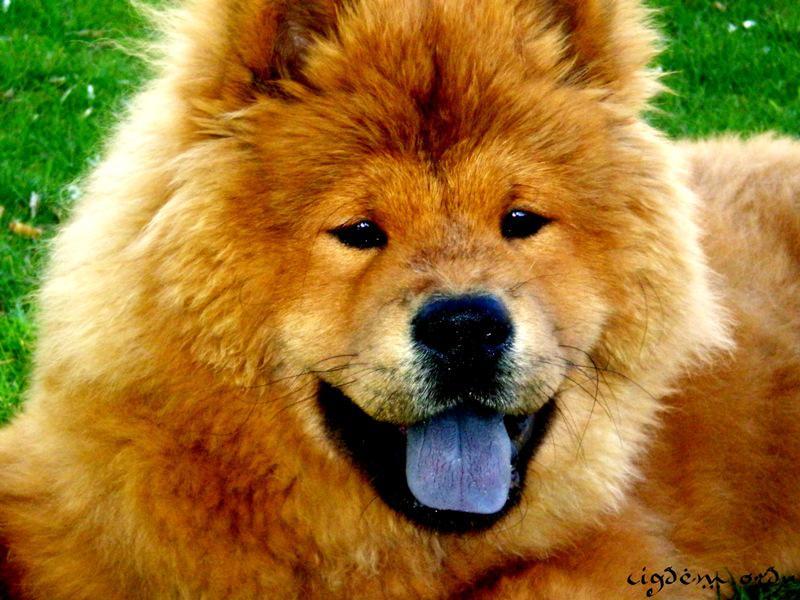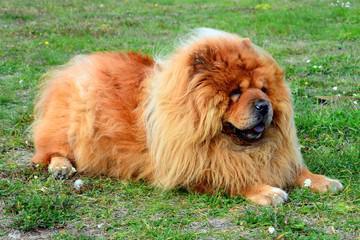The first image is the image on the left, the second image is the image on the right. For the images displayed, is the sentence "The right image includes an adult chow reclining on the grass facing rightward." factually correct? Answer yes or no. Yes. 